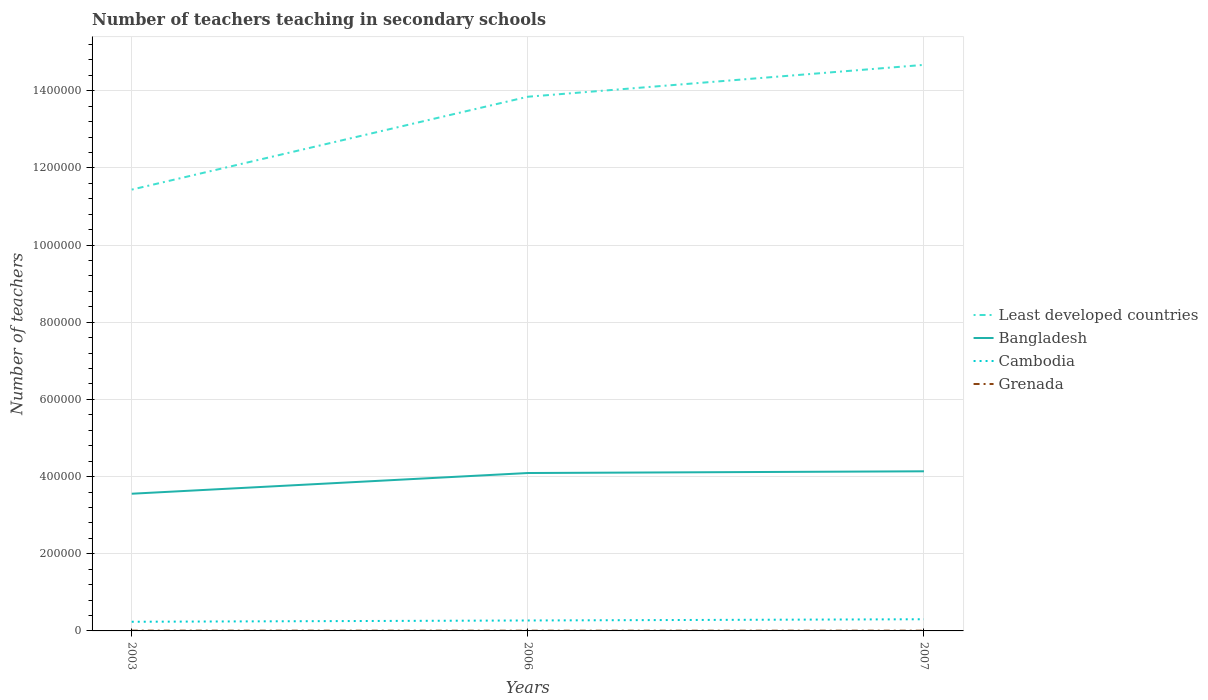How many different coloured lines are there?
Give a very brief answer. 4. Is the number of lines equal to the number of legend labels?
Your answer should be very brief. Yes. Across all years, what is the maximum number of teachers teaching in secondary schools in Least developed countries?
Give a very brief answer. 1.14e+06. In which year was the number of teachers teaching in secondary schools in Cambodia maximum?
Ensure brevity in your answer.  2003. What is the total number of teachers teaching in secondary schools in Least developed countries in the graph?
Your answer should be compact. -2.41e+05. What is the difference between the highest and the second highest number of teachers teaching in secondary schools in Grenada?
Give a very brief answer. 144. What is the difference between the highest and the lowest number of teachers teaching in secondary schools in Cambodia?
Your answer should be very brief. 2. How many years are there in the graph?
Give a very brief answer. 3. What is the difference between two consecutive major ticks on the Y-axis?
Provide a succinct answer. 2.00e+05. Are the values on the major ticks of Y-axis written in scientific E-notation?
Provide a succinct answer. No. Does the graph contain any zero values?
Give a very brief answer. No. Does the graph contain grids?
Your response must be concise. Yes. Where does the legend appear in the graph?
Your answer should be very brief. Center right. How many legend labels are there?
Ensure brevity in your answer.  4. How are the legend labels stacked?
Keep it short and to the point. Vertical. What is the title of the graph?
Ensure brevity in your answer.  Number of teachers teaching in secondary schools. What is the label or title of the Y-axis?
Provide a short and direct response. Number of teachers. What is the Number of teachers in Least developed countries in 2003?
Offer a very short reply. 1.14e+06. What is the Number of teachers of Bangladesh in 2003?
Provide a short and direct response. 3.56e+05. What is the Number of teachers in Cambodia in 2003?
Your answer should be very brief. 2.37e+04. What is the Number of teachers of Grenada in 2003?
Make the answer very short. 740. What is the Number of teachers of Least developed countries in 2006?
Provide a succinct answer. 1.38e+06. What is the Number of teachers of Bangladesh in 2006?
Give a very brief answer. 4.09e+05. What is the Number of teachers in Cambodia in 2006?
Keep it short and to the point. 2.71e+04. What is the Number of teachers of Grenada in 2006?
Offer a terse response. 596. What is the Number of teachers of Least developed countries in 2007?
Make the answer very short. 1.47e+06. What is the Number of teachers of Bangladesh in 2007?
Provide a short and direct response. 4.14e+05. What is the Number of teachers of Cambodia in 2007?
Ensure brevity in your answer.  3.03e+04. What is the Number of teachers of Grenada in 2007?
Offer a very short reply. 642. Across all years, what is the maximum Number of teachers of Least developed countries?
Provide a succinct answer. 1.47e+06. Across all years, what is the maximum Number of teachers of Bangladesh?
Offer a very short reply. 4.14e+05. Across all years, what is the maximum Number of teachers in Cambodia?
Your answer should be compact. 3.03e+04. Across all years, what is the maximum Number of teachers of Grenada?
Provide a short and direct response. 740. Across all years, what is the minimum Number of teachers of Least developed countries?
Make the answer very short. 1.14e+06. Across all years, what is the minimum Number of teachers in Bangladesh?
Provide a short and direct response. 3.56e+05. Across all years, what is the minimum Number of teachers in Cambodia?
Keep it short and to the point. 2.37e+04. Across all years, what is the minimum Number of teachers in Grenada?
Ensure brevity in your answer.  596. What is the total Number of teachers in Least developed countries in the graph?
Provide a succinct answer. 4.00e+06. What is the total Number of teachers in Bangladesh in the graph?
Ensure brevity in your answer.  1.18e+06. What is the total Number of teachers of Cambodia in the graph?
Your answer should be compact. 8.11e+04. What is the total Number of teachers of Grenada in the graph?
Offer a very short reply. 1978. What is the difference between the Number of teachers in Least developed countries in 2003 and that in 2006?
Make the answer very short. -2.41e+05. What is the difference between the Number of teachers of Bangladesh in 2003 and that in 2006?
Keep it short and to the point. -5.37e+04. What is the difference between the Number of teachers in Cambodia in 2003 and that in 2006?
Ensure brevity in your answer.  -3321. What is the difference between the Number of teachers in Grenada in 2003 and that in 2006?
Ensure brevity in your answer.  144. What is the difference between the Number of teachers in Least developed countries in 2003 and that in 2007?
Your answer should be compact. -3.23e+05. What is the difference between the Number of teachers of Bangladesh in 2003 and that in 2007?
Your response must be concise. -5.82e+04. What is the difference between the Number of teachers in Cambodia in 2003 and that in 2007?
Provide a succinct answer. -6509. What is the difference between the Number of teachers in Least developed countries in 2006 and that in 2007?
Your answer should be compact. -8.26e+04. What is the difference between the Number of teachers of Bangladesh in 2006 and that in 2007?
Offer a terse response. -4484. What is the difference between the Number of teachers of Cambodia in 2006 and that in 2007?
Your answer should be compact. -3188. What is the difference between the Number of teachers in Grenada in 2006 and that in 2007?
Offer a very short reply. -46. What is the difference between the Number of teachers of Least developed countries in 2003 and the Number of teachers of Bangladesh in 2006?
Give a very brief answer. 7.35e+05. What is the difference between the Number of teachers of Least developed countries in 2003 and the Number of teachers of Cambodia in 2006?
Give a very brief answer. 1.12e+06. What is the difference between the Number of teachers of Least developed countries in 2003 and the Number of teachers of Grenada in 2006?
Keep it short and to the point. 1.14e+06. What is the difference between the Number of teachers of Bangladesh in 2003 and the Number of teachers of Cambodia in 2006?
Provide a short and direct response. 3.29e+05. What is the difference between the Number of teachers of Bangladesh in 2003 and the Number of teachers of Grenada in 2006?
Ensure brevity in your answer.  3.55e+05. What is the difference between the Number of teachers of Cambodia in 2003 and the Number of teachers of Grenada in 2006?
Your answer should be compact. 2.32e+04. What is the difference between the Number of teachers of Least developed countries in 2003 and the Number of teachers of Bangladesh in 2007?
Your answer should be compact. 7.30e+05. What is the difference between the Number of teachers of Least developed countries in 2003 and the Number of teachers of Cambodia in 2007?
Your answer should be compact. 1.11e+06. What is the difference between the Number of teachers of Least developed countries in 2003 and the Number of teachers of Grenada in 2007?
Make the answer very short. 1.14e+06. What is the difference between the Number of teachers in Bangladesh in 2003 and the Number of teachers in Cambodia in 2007?
Give a very brief answer. 3.25e+05. What is the difference between the Number of teachers in Bangladesh in 2003 and the Number of teachers in Grenada in 2007?
Make the answer very short. 3.55e+05. What is the difference between the Number of teachers of Cambodia in 2003 and the Number of teachers of Grenada in 2007?
Your answer should be compact. 2.31e+04. What is the difference between the Number of teachers in Least developed countries in 2006 and the Number of teachers in Bangladesh in 2007?
Your answer should be compact. 9.71e+05. What is the difference between the Number of teachers in Least developed countries in 2006 and the Number of teachers in Cambodia in 2007?
Your answer should be compact. 1.35e+06. What is the difference between the Number of teachers in Least developed countries in 2006 and the Number of teachers in Grenada in 2007?
Provide a short and direct response. 1.38e+06. What is the difference between the Number of teachers of Bangladesh in 2006 and the Number of teachers of Cambodia in 2007?
Offer a very short reply. 3.79e+05. What is the difference between the Number of teachers in Bangladesh in 2006 and the Number of teachers in Grenada in 2007?
Provide a succinct answer. 4.09e+05. What is the difference between the Number of teachers of Cambodia in 2006 and the Number of teachers of Grenada in 2007?
Offer a very short reply. 2.64e+04. What is the average Number of teachers of Least developed countries per year?
Give a very brief answer. 1.33e+06. What is the average Number of teachers of Bangladesh per year?
Provide a short and direct response. 3.93e+05. What is the average Number of teachers of Cambodia per year?
Offer a terse response. 2.70e+04. What is the average Number of teachers in Grenada per year?
Make the answer very short. 659.33. In the year 2003, what is the difference between the Number of teachers of Least developed countries and Number of teachers of Bangladesh?
Give a very brief answer. 7.88e+05. In the year 2003, what is the difference between the Number of teachers in Least developed countries and Number of teachers in Cambodia?
Provide a short and direct response. 1.12e+06. In the year 2003, what is the difference between the Number of teachers in Least developed countries and Number of teachers in Grenada?
Provide a succinct answer. 1.14e+06. In the year 2003, what is the difference between the Number of teachers of Bangladesh and Number of teachers of Cambodia?
Make the answer very short. 3.32e+05. In the year 2003, what is the difference between the Number of teachers of Bangladesh and Number of teachers of Grenada?
Your response must be concise. 3.55e+05. In the year 2003, what is the difference between the Number of teachers in Cambodia and Number of teachers in Grenada?
Provide a short and direct response. 2.30e+04. In the year 2006, what is the difference between the Number of teachers of Least developed countries and Number of teachers of Bangladesh?
Give a very brief answer. 9.75e+05. In the year 2006, what is the difference between the Number of teachers in Least developed countries and Number of teachers in Cambodia?
Give a very brief answer. 1.36e+06. In the year 2006, what is the difference between the Number of teachers of Least developed countries and Number of teachers of Grenada?
Your response must be concise. 1.38e+06. In the year 2006, what is the difference between the Number of teachers of Bangladesh and Number of teachers of Cambodia?
Keep it short and to the point. 3.82e+05. In the year 2006, what is the difference between the Number of teachers in Bangladesh and Number of teachers in Grenada?
Make the answer very short. 4.09e+05. In the year 2006, what is the difference between the Number of teachers of Cambodia and Number of teachers of Grenada?
Your answer should be very brief. 2.65e+04. In the year 2007, what is the difference between the Number of teachers in Least developed countries and Number of teachers in Bangladesh?
Offer a terse response. 1.05e+06. In the year 2007, what is the difference between the Number of teachers of Least developed countries and Number of teachers of Cambodia?
Your answer should be compact. 1.44e+06. In the year 2007, what is the difference between the Number of teachers of Least developed countries and Number of teachers of Grenada?
Offer a terse response. 1.47e+06. In the year 2007, what is the difference between the Number of teachers of Bangladesh and Number of teachers of Cambodia?
Keep it short and to the point. 3.83e+05. In the year 2007, what is the difference between the Number of teachers of Bangladesh and Number of teachers of Grenada?
Provide a succinct answer. 4.13e+05. In the year 2007, what is the difference between the Number of teachers in Cambodia and Number of teachers in Grenada?
Your answer should be compact. 2.96e+04. What is the ratio of the Number of teachers of Least developed countries in 2003 to that in 2006?
Offer a terse response. 0.83. What is the ratio of the Number of teachers in Bangladesh in 2003 to that in 2006?
Give a very brief answer. 0.87. What is the ratio of the Number of teachers of Cambodia in 2003 to that in 2006?
Offer a very short reply. 0.88. What is the ratio of the Number of teachers in Grenada in 2003 to that in 2006?
Make the answer very short. 1.24. What is the ratio of the Number of teachers of Least developed countries in 2003 to that in 2007?
Provide a short and direct response. 0.78. What is the ratio of the Number of teachers in Bangladesh in 2003 to that in 2007?
Keep it short and to the point. 0.86. What is the ratio of the Number of teachers of Cambodia in 2003 to that in 2007?
Offer a terse response. 0.78. What is the ratio of the Number of teachers in Grenada in 2003 to that in 2007?
Provide a succinct answer. 1.15. What is the ratio of the Number of teachers in Least developed countries in 2006 to that in 2007?
Provide a short and direct response. 0.94. What is the ratio of the Number of teachers in Bangladesh in 2006 to that in 2007?
Offer a terse response. 0.99. What is the ratio of the Number of teachers in Cambodia in 2006 to that in 2007?
Ensure brevity in your answer.  0.89. What is the ratio of the Number of teachers in Grenada in 2006 to that in 2007?
Offer a terse response. 0.93. What is the difference between the highest and the second highest Number of teachers of Least developed countries?
Provide a short and direct response. 8.26e+04. What is the difference between the highest and the second highest Number of teachers of Bangladesh?
Keep it short and to the point. 4484. What is the difference between the highest and the second highest Number of teachers in Cambodia?
Your answer should be very brief. 3188. What is the difference between the highest and the second highest Number of teachers of Grenada?
Give a very brief answer. 98. What is the difference between the highest and the lowest Number of teachers of Least developed countries?
Give a very brief answer. 3.23e+05. What is the difference between the highest and the lowest Number of teachers of Bangladesh?
Provide a short and direct response. 5.82e+04. What is the difference between the highest and the lowest Number of teachers in Cambodia?
Offer a terse response. 6509. What is the difference between the highest and the lowest Number of teachers in Grenada?
Ensure brevity in your answer.  144. 